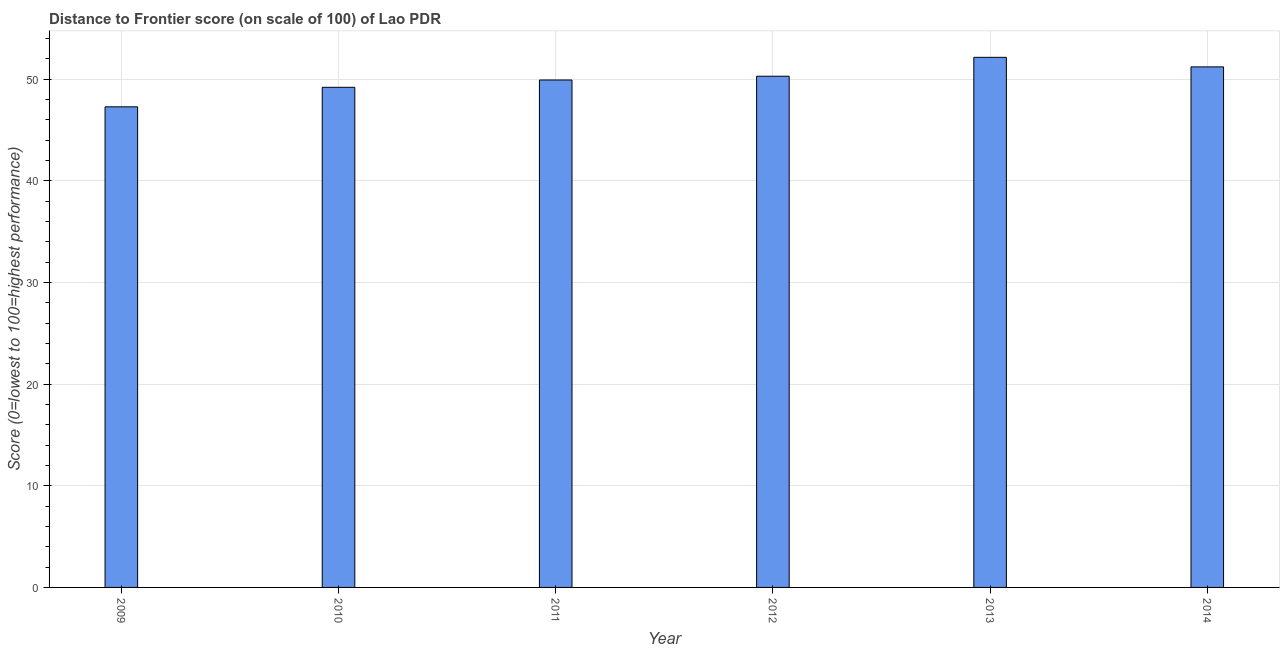What is the title of the graph?
Make the answer very short. Distance to Frontier score (on scale of 100) of Lao PDR. What is the label or title of the X-axis?
Give a very brief answer. Year. What is the label or title of the Y-axis?
Keep it short and to the point. Score (0=lowest to 100=highest performance). What is the distance to frontier score in 2011?
Provide a short and direct response. 49.93. Across all years, what is the maximum distance to frontier score?
Provide a succinct answer. 52.16. Across all years, what is the minimum distance to frontier score?
Ensure brevity in your answer.  47.29. In which year was the distance to frontier score maximum?
Give a very brief answer. 2013. In which year was the distance to frontier score minimum?
Provide a succinct answer. 2009. What is the sum of the distance to frontier score?
Your answer should be compact. 300.11. What is the difference between the distance to frontier score in 2011 and 2014?
Provide a succinct answer. -1.29. What is the average distance to frontier score per year?
Give a very brief answer. 50.02. What is the median distance to frontier score?
Offer a very short reply. 50.11. Is the distance to frontier score in 2010 less than that in 2011?
Make the answer very short. Yes. Is the difference between the distance to frontier score in 2009 and 2013 greater than the difference between any two years?
Provide a short and direct response. Yes. What is the difference between the highest and the second highest distance to frontier score?
Keep it short and to the point. 0.94. What is the difference between the highest and the lowest distance to frontier score?
Your answer should be very brief. 4.87. In how many years, is the distance to frontier score greater than the average distance to frontier score taken over all years?
Ensure brevity in your answer.  3. How many bars are there?
Your response must be concise. 6. How many years are there in the graph?
Provide a succinct answer. 6. What is the difference between two consecutive major ticks on the Y-axis?
Ensure brevity in your answer.  10. What is the Score (0=lowest to 100=highest performance) in 2009?
Offer a terse response. 47.29. What is the Score (0=lowest to 100=highest performance) of 2010?
Provide a succinct answer. 49.21. What is the Score (0=lowest to 100=highest performance) in 2011?
Your answer should be very brief. 49.93. What is the Score (0=lowest to 100=highest performance) of 2012?
Your answer should be compact. 50.3. What is the Score (0=lowest to 100=highest performance) in 2013?
Give a very brief answer. 52.16. What is the Score (0=lowest to 100=highest performance) of 2014?
Your answer should be compact. 51.22. What is the difference between the Score (0=lowest to 100=highest performance) in 2009 and 2010?
Provide a succinct answer. -1.92. What is the difference between the Score (0=lowest to 100=highest performance) in 2009 and 2011?
Provide a short and direct response. -2.64. What is the difference between the Score (0=lowest to 100=highest performance) in 2009 and 2012?
Your answer should be very brief. -3.01. What is the difference between the Score (0=lowest to 100=highest performance) in 2009 and 2013?
Make the answer very short. -4.87. What is the difference between the Score (0=lowest to 100=highest performance) in 2009 and 2014?
Ensure brevity in your answer.  -3.93. What is the difference between the Score (0=lowest to 100=highest performance) in 2010 and 2011?
Your response must be concise. -0.72. What is the difference between the Score (0=lowest to 100=highest performance) in 2010 and 2012?
Your answer should be very brief. -1.09. What is the difference between the Score (0=lowest to 100=highest performance) in 2010 and 2013?
Offer a very short reply. -2.95. What is the difference between the Score (0=lowest to 100=highest performance) in 2010 and 2014?
Give a very brief answer. -2.01. What is the difference between the Score (0=lowest to 100=highest performance) in 2011 and 2012?
Make the answer very short. -0.37. What is the difference between the Score (0=lowest to 100=highest performance) in 2011 and 2013?
Your answer should be compact. -2.23. What is the difference between the Score (0=lowest to 100=highest performance) in 2011 and 2014?
Your answer should be very brief. -1.29. What is the difference between the Score (0=lowest to 100=highest performance) in 2012 and 2013?
Offer a very short reply. -1.86. What is the difference between the Score (0=lowest to 100=highest performance) in 2012 and 2014?
Keep it short and to the point. -0.92. What is the ratio of the Score (0=lowest to 100=highest performance) in 2009 to that in 2010?
Provide a succinct answer. 0.96. What is the ratio of the Score (0=lowest to 100=highest performance) in 2009 to that in 2011?
Make the answer very short. 0.95. What is the ratio of the Score (0=lowest to 100=highest performance) in 2009 to that in 2012?
Offer a very short reply. 0.94. What is the ratio of the Score (0=lowest to 100=highest performance) in 2009 to that in 2013?
Keep it short and to the point. 0.91. What is the ratio of the Score (0=lowest to 100=highest performance) in 2009 to that in 2014?
Provide a short and direct response. 0.92. What is the ratio of the Score (0=lowest to 100=highest performance) in 2010 to that in 2013?
Make the answer very short. 0.94. What is the ratio of the Score (0=lowest to 100=highest performance) in 2010 to that in 2014?
Keep it short and to the point. 0.96. What is the ratio of the Score (0=lowest to 100=highest performance) in 2012 to that in 2014?
Your answer should be compact. 0.98. What is the ratio of the Score (0=lowest to 100=highest performance) in 2013 to that in 2014?
Provide a short and direct response. 1.02. 